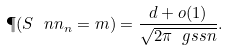Convert formula to latex. <formula><loc_0><loc_0><loc_500><loc_500>\P ( S \ n n _ { n } = m ) = \frac { d + o ( 1 ) } { \sqrt { 2 \pi \ g s s n } } .</formula> 